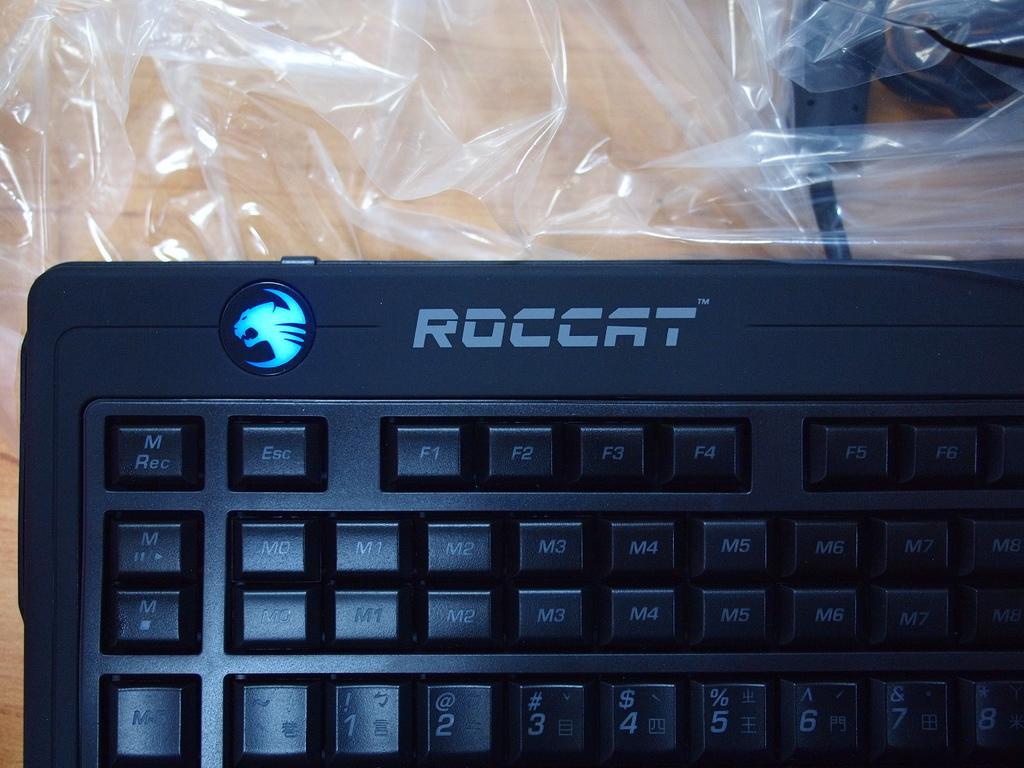What type of keyboard is on the table in the image? There is a black color keyboard on the table. What else can be seen in the image besides the keyboard? Cables are visible in the image. Is there any protective covering for the keyboard in the image? Yes, there is a plastic cover in the image. What type of yam is being used as a reaction to the watch in the image? There is no yam or watch present in the image, so this question cannot be answered. 